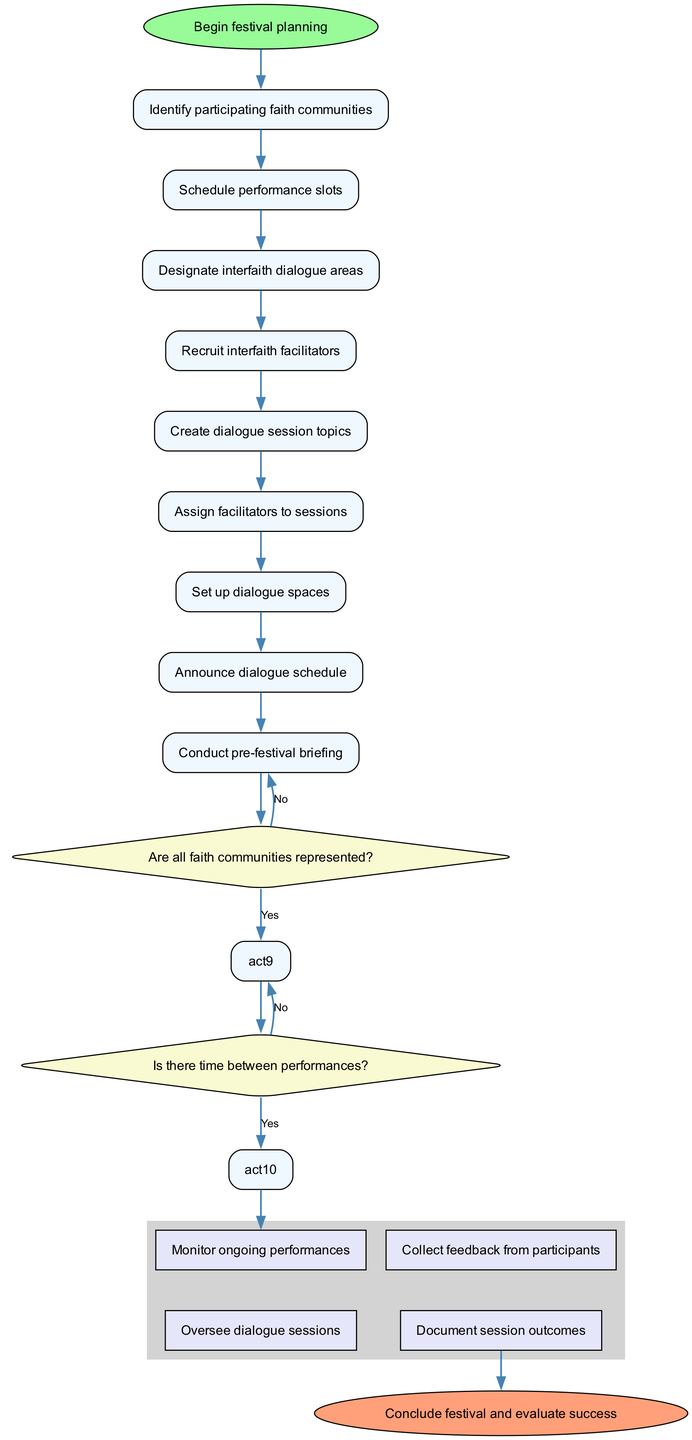How many activities are listed in the diagram? The diagram lists a total of eight activities, which are connected in sequential order from the start node.
Answer: 8 What is the first activity in the workflow? The first activity in the workflow, following the start node, is "Identify participating faith communities." This is the initial task in the planning process.
Answer: Identify participating faith communities What happens if not all faith communities are represented? If not all faith communities are represented, the workflow indicates that the next step is to "Reach out to underrepresented groups." This is a decision point leading to this action.
Answer: Reach out to underrepresented groups Which activity follows "Conduct pre-festival briefing" if there is time between performances? If there is time between performances, the next activity that follows "Conduct pre-festival briefing" is "Schedule dialogue sessions," as indicated in the decision node that allows for this scheduling.
Answer: Schedule dialogue sessions What are the two parallel activities started after scheduling dialogue sessions? The two parallel activities are "Monitor ongoing performances" and "Oversee dialogue sessions." Both activities begin concurrently after the scheduling is established.
Answer: Monitor ongoing performances, Oversee dialogue sessions What determines whether to adjust the performance schedule? Whether to adjust the performance schedule is determined by the condition of having time between performances. If the answer is 'no,' then an adjustment is required.
Answer: Is there time between performances? What is the final node of the workflow? The final node of the workflow is labeled "Conclude festival and evaluate success," which signifies the end of the planning and execution process.
Answer: Conclude festival and evaluate success What do we need to do after assigning facilitators to sessions? After assigning facilitators to sessions, the next step is to "Set up dialogue spaces" in preparation for the upcoming dialogue sessions.
Answer: Set up dialogue spaces What is the condition checked after "Create dialogue session topics"? After "Create dialogue session topics," the condition checked is "Are all faith communities represented?" This decision influences the following action in the process.
Answer: Are all faith communities represented? 